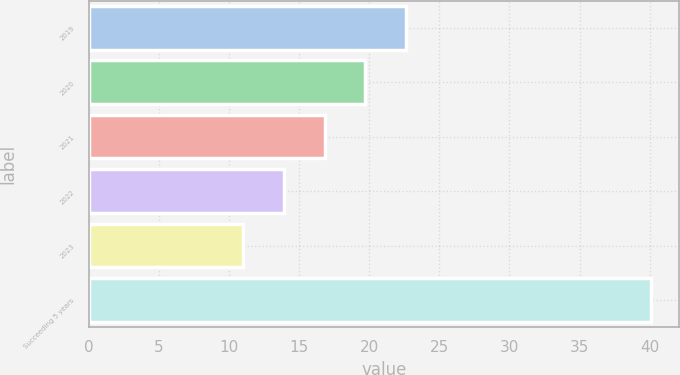<chart> <loc_0><loc_0><loc_500><loc_500><bar_chart><fcel>2019<fcel>2020<fcel>2021<fcel>2022<fcel>2023<fcel>Succeeding 5 years<nl><fcel>22.64<fcel>19.73<fcel>16.82<fcel>13.91<fcel>11<fcel>40.1<nl></chart> 